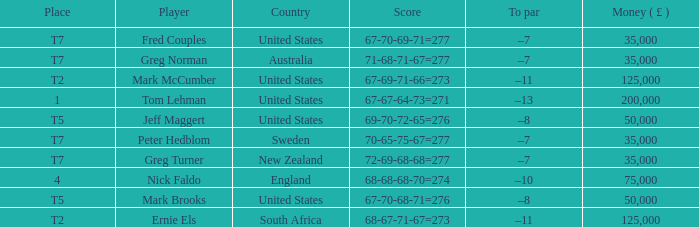What is To par, when Country is "United States", when Money ( £ ) is greater than 125,000, and when Score is "67-70-68-71=276"? None. 